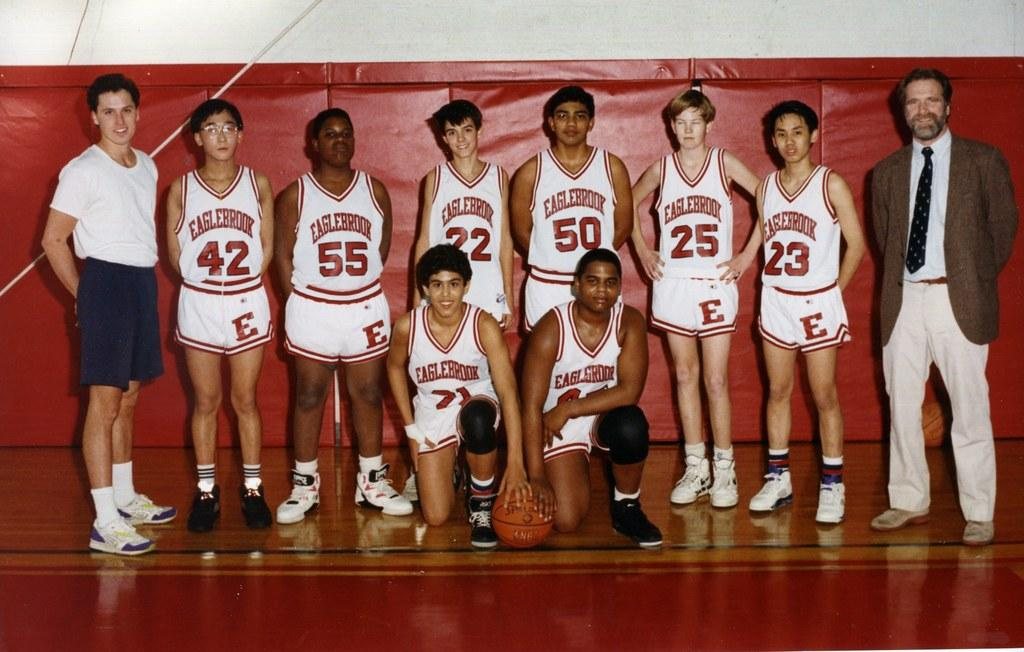<image>
Offer a succinct explanation of the picture presented. The Eaglebrook basketball team poses for a photo. 